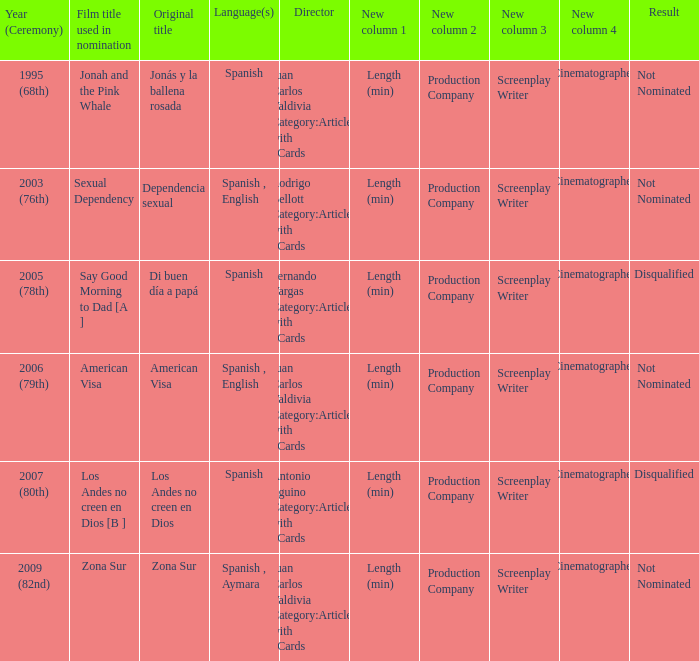What was zona sur's outcome after being considered for nomination? Not Nominated. 